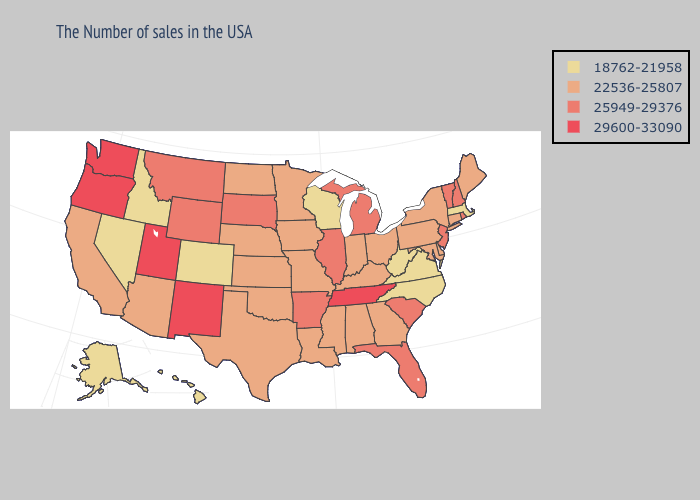Does the first symbol in the legend represent the smallest category?
Be succinct. Yes. Does Oklahoma have the same value as North Carolina?
Keep it brief. No. Name the states that have a value in the range 22536-25807?
Answer briefly. Maine, Connecticut, New York, Delaware, Maryland, Pennsylvania, Ohio, Georgia, Kentucky, Indiana, Alabama, Mississippi, Louisiana, Missouri, Minnesota, Iowa, Kansas, Nebraska, Oklahoma, Texas, North Dakota, Arizona, California. What is the lowest value in states that border Oklahoma?
Quick response, please. 18762-21958. What is the value of Mississippi?
Give a very brief answer. 22536-25807. Which states have the lowest value in the Northeast?
Keep it brief. Massachusetts. What is the value of Nebraska?
Quick response, please. 22536-25807. Name the states that have a value in the range 25949-29376?
Answer briefly. Rhode Island, New Hampshire, Vermont, New Jersey, South Carolina, Florida, Michigan, Illinois, Arkansas, South Dakota, Wyoming, Montana. Among the states that border Indiana , which have the highest value?
Answer briefly. Michigan, Illinois. Among the states that border Louisiana , which have the highest value?
Short answer required. Arkansas. Name the states that have a value in the range 29600-33090?
Short answer required. Tennessee, New Mexico, Utah, Washington, Oregon. Name the states that have a value in the range 22536-25807?
Be succinct. Maine, Connecticut, New York, Delaware, Maryland, Pennsylvania, Ohio, Georgia, Kentucky, Indiana, Alabama, Mississippi, Louisiana, Missouri, Minnesota, Iowa, Kansas, Nebraska, Oklahoma, Texas, North Dakota, Arizona, California. What is the value of Utah?
Quick response, please. 29600-33090. Among the states that border Texas , does Oklahoma have the highest value?
Answer briefly. No. 